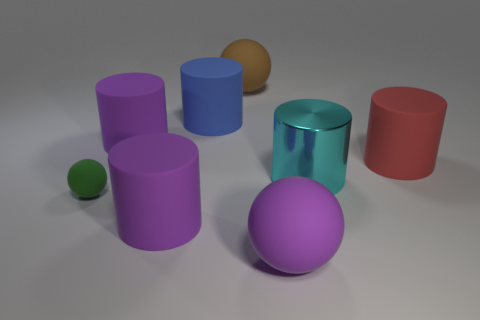Subtract all blue matte cylinders. How many cylinders are left? 4 Subtract all red cylinders. How many cylinders are left? 4 Subtract all yellow cylinders. Subtract all red blocks. How many cylinders are left? 5 Add 1 cylinders. How many objects exist? 9 Subtract all cylinders. How many objects are left? 3 Add 8 green matte spheres. How many green matte spheres are left? 9 Add 6 yellow matte things. How many yellow matte things exist? 6 Subtract 0 gray cylinders. How many objects are left? 8 Subtract all gray objects. Subtract all big rubber spheres. How many objects are left? 6 